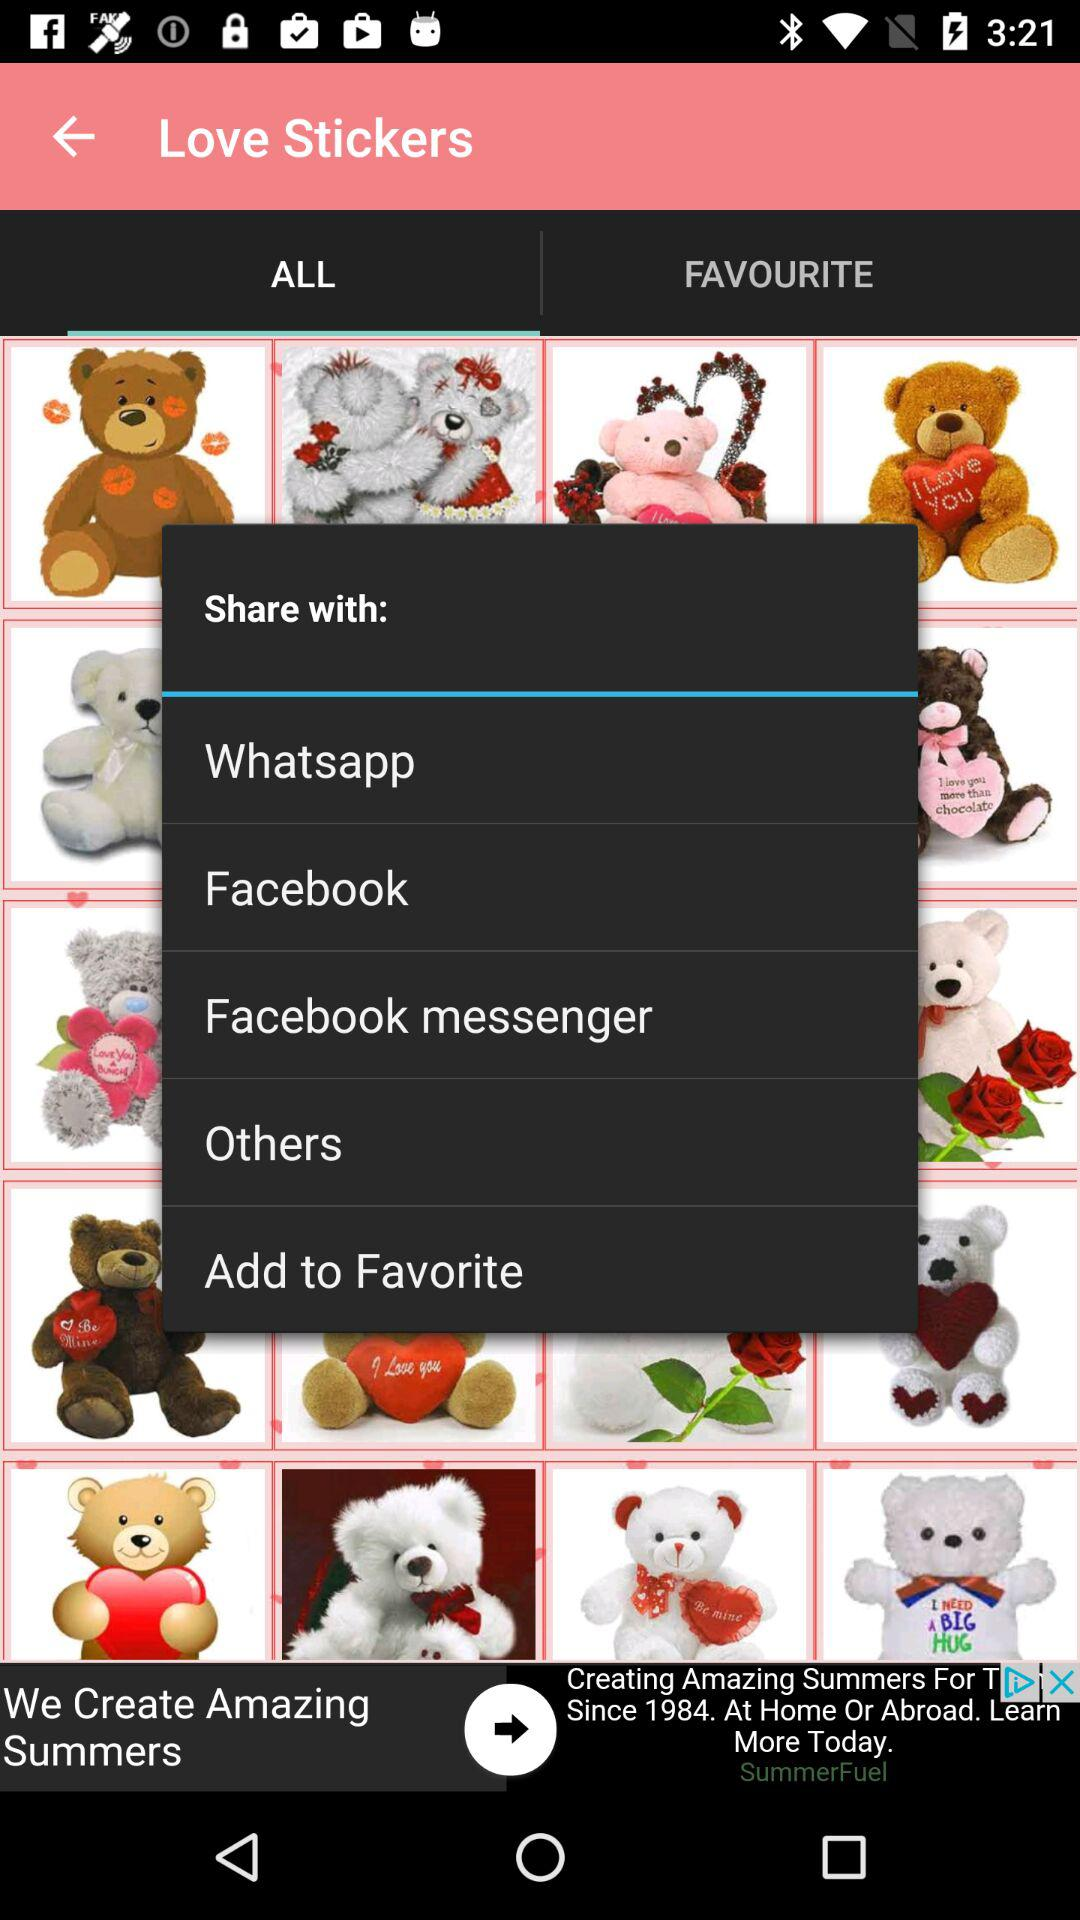Through which applications can it be shared? It can be shared through "Whatsapp", "Facebook" and "Facebook messenger". 